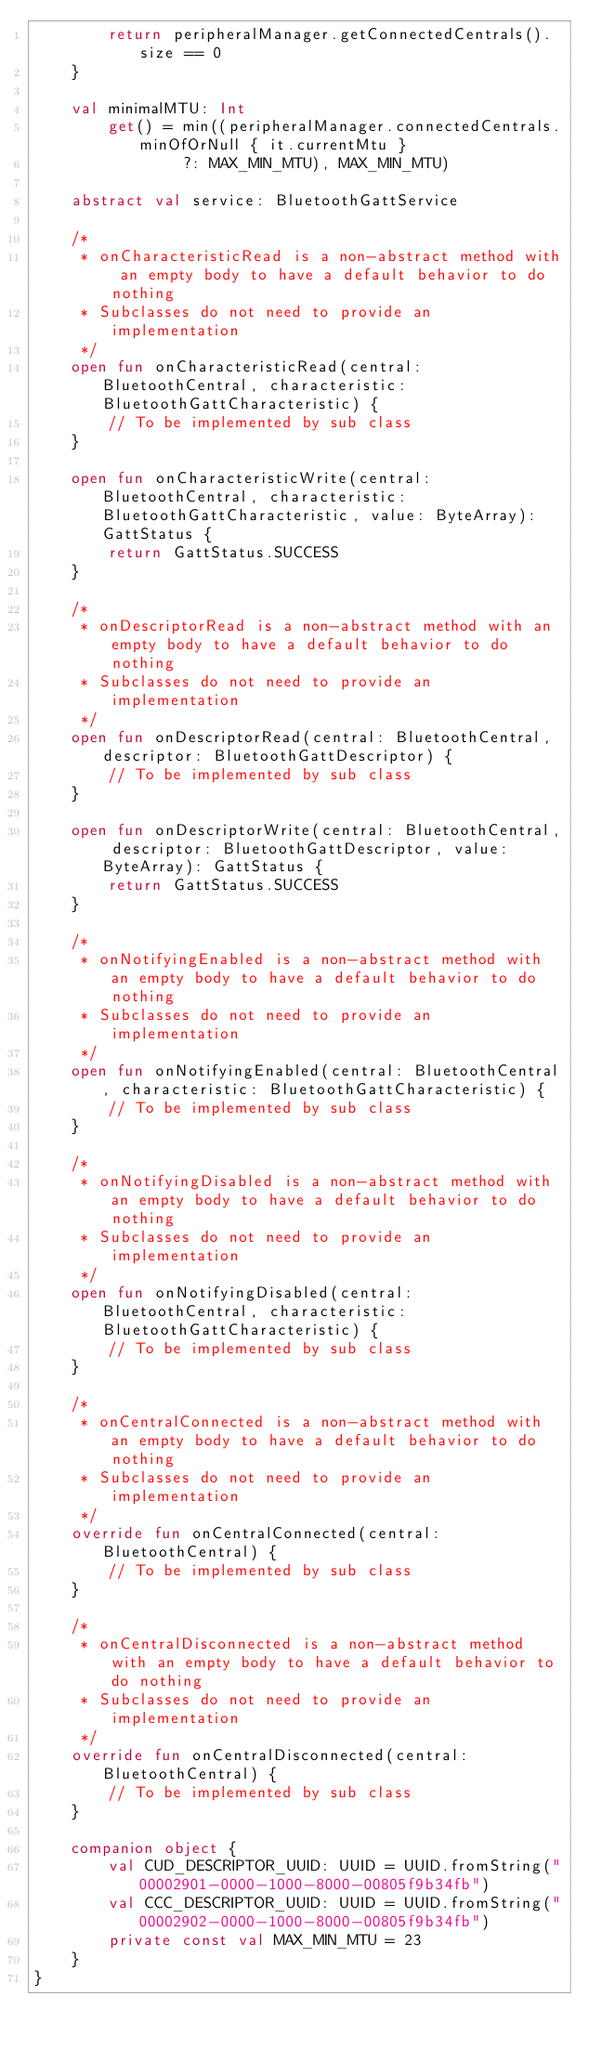<code> <loc_0><loc_0><loc_500><loc_500><_Kotlin_>        return peripheralManager.getConnectedCentrals().size == 0
    }

    val minimalMTU: Int
        get() = min((peripheralManager.connectedCentrals.minOfOrNull { it.currentMtu }
                ?: MAX_MIN_MTU), MAX_MIN_MTU)

    abstract val service: BluetoothGattService

    /*
     * onCharacteristicRead is a non-abstract method with an empty body to have a default behavior to do nothing
     * Subclasses do not need to provide an implementation
     */
    open fun onCharacteristicRead(central: BluetoothCentral, characteristic: BluetoothGattCharacteristic) {
        // To be implemented by sub class
    }

    open fun onCharacteristicWrite(central: BluetoothCentral, characteristic: BluetoothGattCharacteristic, value: ByteArray): GattStatus {
        return GattStatus.SUCCESS
    }

    /*
     * onDescriptorRead is a non-abstract method with an empty body to have a default behavior to do nothing
     * Subclasses do not need to provide an implementation
     */
    open fun onDescriptorRead(central: BluetoothCentral, descriptor: BluetoothGattDescriptor) {
        // To be implemented by sub class
    }

    open fun onDescriptorWrite(central: BluetoothCentral, descriptor: BluetoothGattDescriptor, value: ByteArray): GattStatus {
        return GattStatus.SUCCESS
    }

    /*
     * onNotifyingEnabled is a non-abstract method with an empty body to have a default behavior to do nothing
     * Subclasses do not need to provide an implementation
     */
    open fun onNotifyingEnabled(central: BluetoothCentral, characteristic: BluetoothGattCharacteristic) {
        // To be implemented by sub class
    }

    /*
     * onNotifyingDisabled is a non-abstract method with an empty body to have a default behavior to do nothing
     * Subclasses do not need to provide an implementation
     */
    open fun onNotifyingDisabled(central: BluetoothCentral, characteristic: BluetoothGattCharacteristic) {
        // To be implemented by sub class
    }

    /*
     * onCentralConnected is a non-abstract method with an empty body to have a default behavior to do nothing
     * Subclasses do not need to provide an implementation
     */
    override fun onCentralConnected(central: BluetoothCentral) {
        // To be implemented by sub class
    }

    /*
     * onCentralDisconnected is a non-abstract method with an empty body to have a default behavior to do nothing
     * Subclasses do not need to provide an implementation
     */
    override fun onCentralDisconnected(central: BluetoothCentral) {
        // To be implemented by sub class
    }

    companion object {
        val CUD_DESCRIPTOR_UUID: UUID = UUID.fromString("00002901-0000-1000-8000-00805f9b34fb")
        val CCC_DESCRIPTOR_UUID: UUID = UUID.fromString("00002902-0000-1000-8000-00805f9b34fb")
        private const val MAX_MIN_MTU = 23
    }
}
</code> 